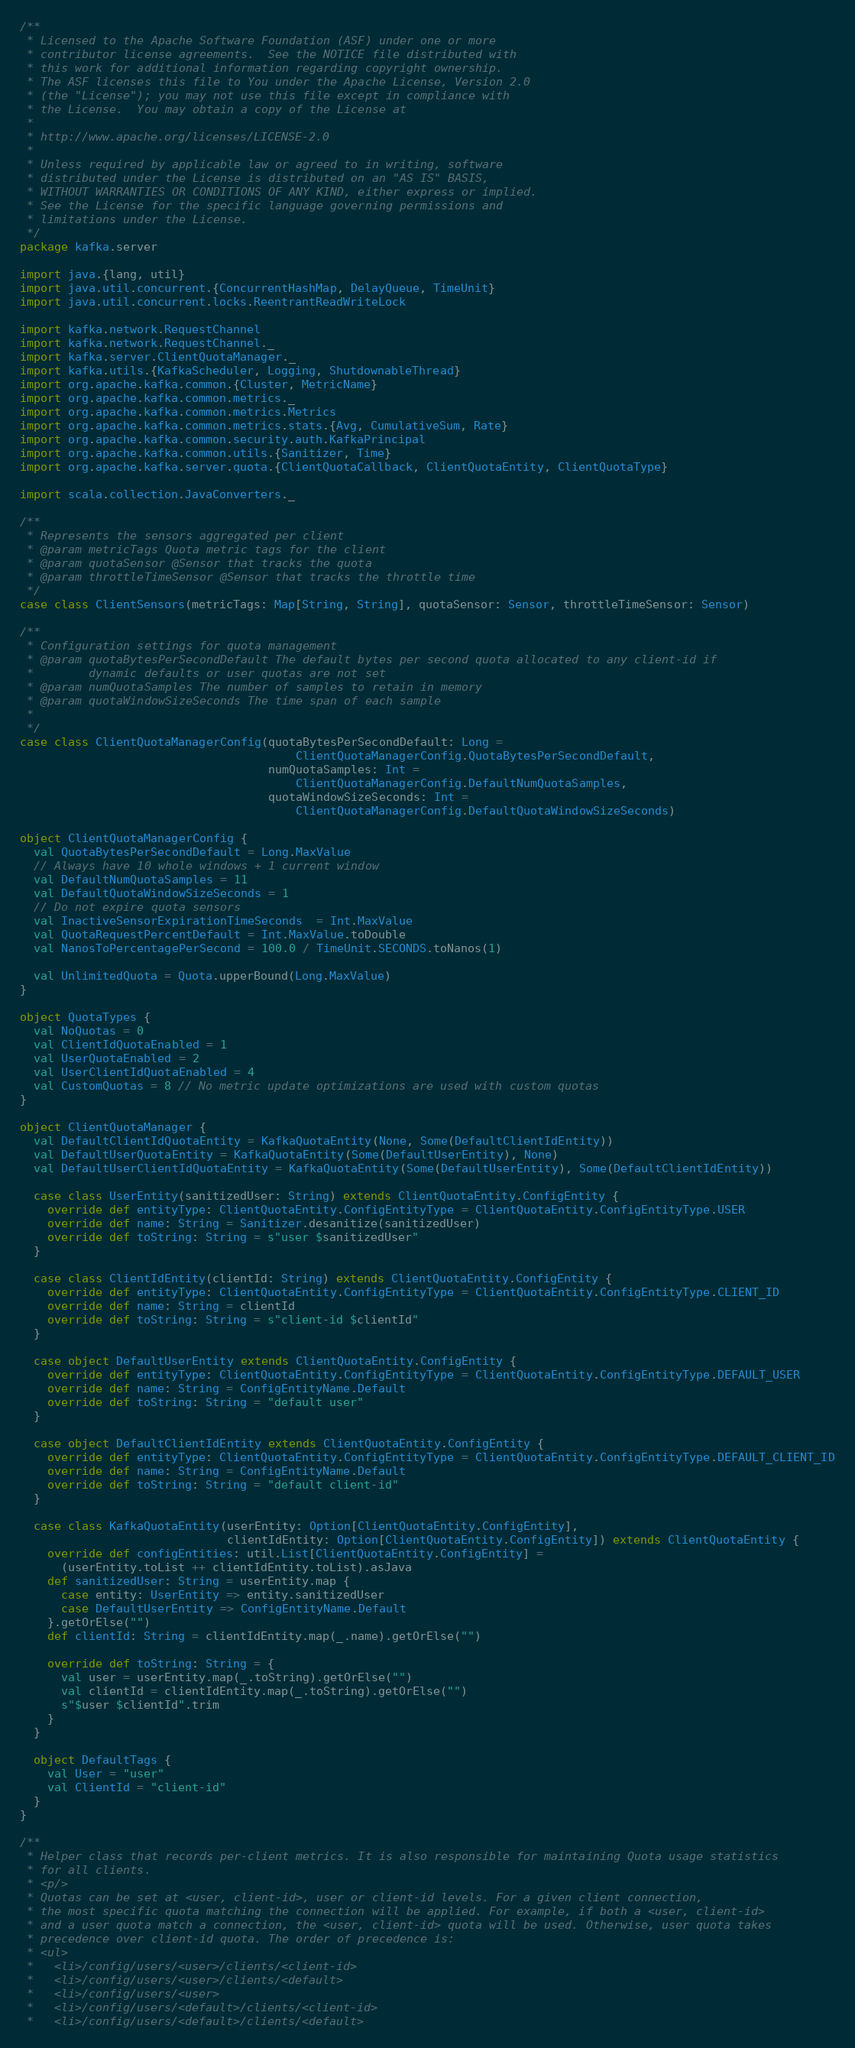Convert code to text. <code><loc_0><loc_0><loc_500><loc_500><_Scala_>/**
 * Licensed to the Apache Software Foundation (ASF) under one or more
 * contributor license agreements.  See the NOTICE file distributed with
 * this work for additional information regarding copyright ownership.
 * The ASF licenses this file to You under the Apache License, Version 2.0
 * (the "License"); you may not use this file except in compliance with
 * the License.  You may obtain a copy of the License at
 *
 * http://www.apache.org/licenses/LICENSE-2.0
 *
 * Unless required by applicable law or agreed to in writing, software
 * distributed under the License is distributed on an "AS IS" BASIS,
 * WITHOUT WARRANTIES OR CONDITIONS OF ANY KIND, either express or implied.
 * See the License for the specific language governing permissions and
 * limitations under the License.
 */
package kafka.server

import java.{lang, util}
import java.util.concurrent.{ConcurrentHashMap, DelayQueue, TimeUnit}
import java.util.concurrent.locks.ReentrantReadWriteLock

import kafka.network.RequestChannel
import kafka.network.RequestChannel._
import kafka.server.ClientQuotaManager._
import kafka.utils.{KafkaScheduler, Logging, ShutdownableThread}
import org.apache.kafka.common.{Cluster, MetricName}
import org.apache.kafka.common.metrics._
import org.apache.kafka.common.metrics.Metrics
import org.apache.kafka.common.metrics.stats.{Avg, CumulativeSum, Rate}
import org.apache.kafka.common.security.auth.KafkaPrincipal
import org.apache.kafka.common.utils.{Sanitizer, Time}
import org.apache.kafka.server.quota.{ClientQuotaCallback, ClientQuotaEntity, ClientQuotaType}

import scala.collection.JavaConverters._

/**
 * Represents the sensors aggregated per client
 * @param metricTags Quota metric tags for the client
 * @param quotaSensor @Sensor that tracks the quota
 * @param throttleTimeSensor @Sensor that tracks the throttle time
 */
case class ClientSensors(metricTags: Map[String, String], quotaSensor: Sensor, throttleTimeSensor: Sensor)

/**
 * Configuration settings for quota management
 * @param quotaBytesPerSecondDefault The default bytes per second quota allocated to any client-id if
 *        dynamic defaults or user quotas are not set
 * @param numQuotaSamples The number of samples to retain in memory
 * @param quotaWindowSizeSeconds The time span of each sample
 *
 */
case class ClientQuotaManagerConfig(quotaBytesPerSecondDefault: Long =
                                        ClientQuotaManagerConfig.QuotaBytesPerSecondDefault,
                                    numQuotaSamples: Int =
                                        ClientQuotaManagerConfig.DefaultNumQuotaSamples,
                                    quotaWindowSizeSeconds: Int =
                                        ClientQuotaManagerConfig.DefaultQuotaWindowSizeSeconds)

object ClientQuotaManagerConfig {
  val QuotaBytesPerSecondDefault = Long.MaxValue
  // Always have 10 whole windows + 1 current window
  val DefaultNumQuotaSamples = 11
  val DefaultQuotaWindowSizeSeconds = 1
  // Do not expire quota sensors
  val InactiveSensorExpirationTimeSeconds  = Int.MaxValue
  val QuotaRequestPercentDefault = Int.MaxValue.toDouble
  val NanosToPercentagePerSecond = 100.0 / TimeUnit.SECONDS.toNanos(1)

  val UnlimitedQuota = Quota.upperBound(Long.MaxValue)
}

object QuotaTypes {
  val NoQuotas = 0
  val ClientIdQuotaEnabled = 1
  val UserQuotaEnabled = 2
  val UserClientIdQuotaEnabled = 4
  val CustomQuotas = 8 // No metric update optimizations are used with custom quotas
}

object ClientQuotaManager {
  val DefaultClientIdQuotaEntity = KafkaQuotaEntity(None, Some(DefaultClientIdEntity))
  val DefaultUserQuotaEntity = KafkaQuotaEntity(Some(DefaultUserEntity), None)
  val DefaultUserClientIdQuotaEntity = KafkaQuotaEntity(Some(DefaultUserEntity), Some(DefaultClientIdEntity))

  case class UserEntity(sanitizedUser: String) extends ClientQuotaEntity.ConfigEntity {
    override def entityType: ClientQuotaEntity.ConfigEntityType = ClientQuotaEntity.ConfigEntityType.USER
    override def name: String = Sanitizer.desanitize(sanitizedUser)
    override def toString: String = s"user $sanitizedUser"
  }

  case class ClientIdEntity(clientId: String) extends ClientQuotaEntity.ConfigEntity {
    override def entityType: ClientQuotaEntity.ConfigEntityType = ClientQuotaEntity.ConfigEntityType.CLIENT_ID
    override def name: String = clientId
    override def toString: String = s"client-id $clientId"
  }

  case object DefaultUserEntity extends ClientQuotaEntity.ConfigEntity {
    override def entityType: ClientQuotaEntity.ConfigEntityType = ClientQuotaEntity.ConfigEntityType.DEFAULT_USER
    override def name: String = ConfigEntityName.Default
    override def toString: String = "default user"
  }

  case object DefaultClientIdEntity extends ClientQuotaEntity.ConfigEntity {
    override def entityType: ClientQuotaEntity.ConfigEntityType = ClientQuotaEntity.ConfigEntityType.DEFAULT_CLIENT_ID
    override def name: String = ConfigEntityName.Default
    override def toString: String = "default client-id"
  }

  case class KafkaQuotaEntity(userEntity: Option[ClientQuotaEntity.ConfigEntity],
                              clientIdEntity: Option[ClientQuotaEntity.ConfigEntity]) extends ClientQuotaEntity {
    override def configEntities: util.List[ClientQuotaEntity.ConfigEntity] =
      (userEntity.toList ++ clientIdEntity.toList).asJava
    def sanitizedUser: String = userEntity.map {
      case entity: UserEntity => entity.sanitizedUser
      case DefaultUserEntity => ConfigEntityName.Default
    }.getOrElse("")
    def clientId: String = clientIdEntity.map(_.name).getOrElse("")

    override def toString: String = {
      val user = userEntity.map(_.toString).getOrElse("")
      val clientId = clientIdEntity.map(_.toString).getOrElse("")
      s"$user $clientId".trim
    }
  }

  object DefaultTags {
    val User = "user"
    val ClientId = "client-id"
  }
}

/**
 * Helper class that records per-client metrics. It is also responsible for maintaining Quota usage statistics
 * for all clients.
 * <p/>
 * Quotas can be set at <user, client-id>, user or client-id levels. For a given client connection,
 * the most specific quota matching the connection will be applied. For example, if both a <user, client-id>
 * and a user quota match a connection, the <user, client-id> quota will be used. Otherwise, user quota takes
 * precedence over client-id quota. The order of precedence is:
 * <ul>
 *   <li>/config/users/<user>/clients/<client-id>
 *   <li>/config/users/<user>/clients/<default>
 *   <li>/config/users/<user>
 *   <li>/config/users/<default>/clients/<client-id>
 *   <li>/config/users/<default>/clients/<default></code> 